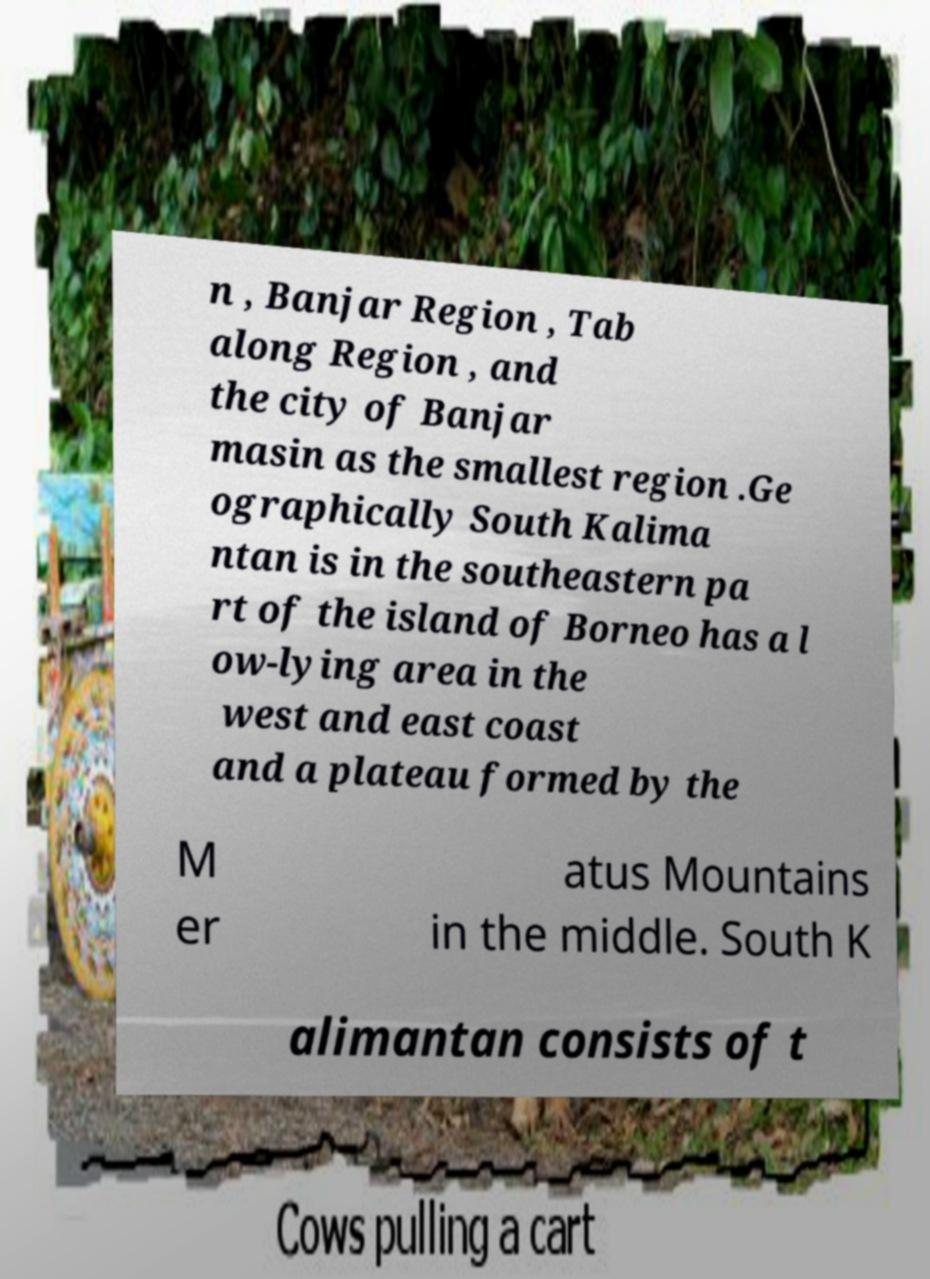What messages or text are displayed in this image? I need them in a readable, typed format. n , Banjar Region , Tab along Region , and the city of Banjar masin as the smallest region .Ge ographically South Kalima ntan is in the southeastern pa rt of the island of Borneo has a l ow-lying area in the west and east coast and a plateau formed by the M er atus Mountains in the middle. South K alimantan consists of t 